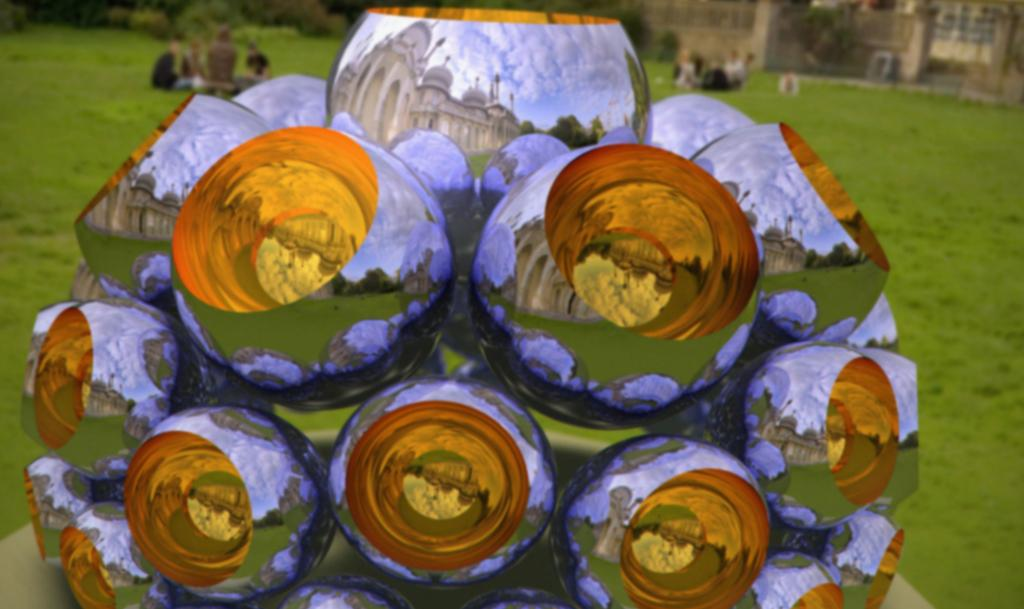What can be seen in the image besides the decorative objects? In the background of the image, there are people sitting on the grass and buildings and plants visible. Can you describe the setting of the image? The image features decorative objects and a background with people sitting on the grass, buildings, and plants. What type of vegetation is present in the image? The plants visible in the background of the image are part of the vegetation present. What does the sister of the person taking the photo smell in the image? There is no reference to a sister or any smells in the image, so it is not possible to answer that question. 